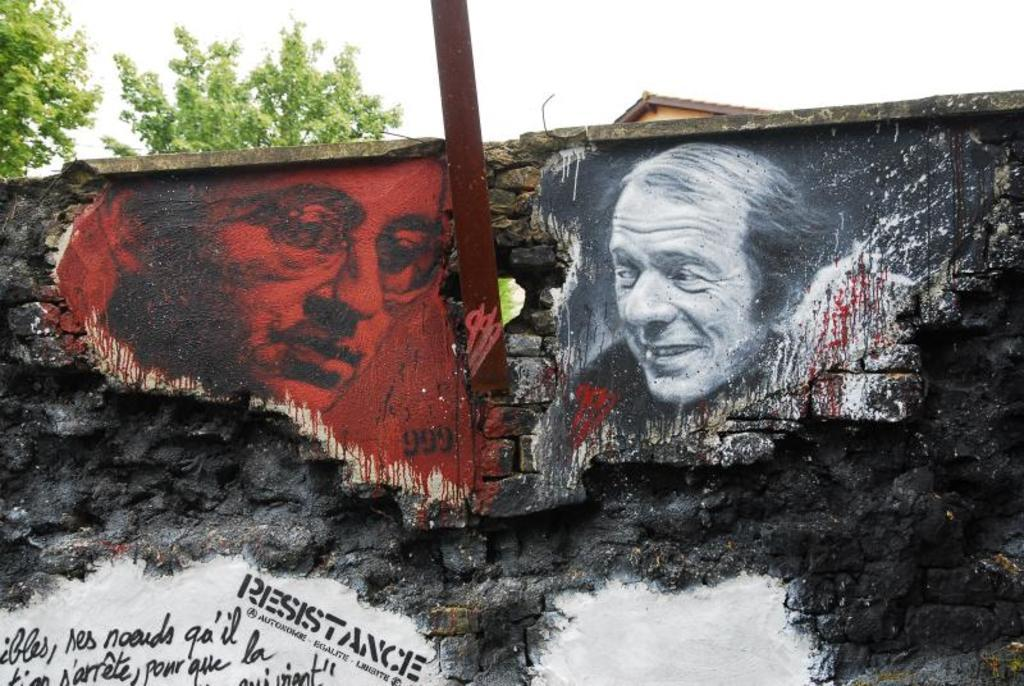What is present on the wall in the image? There are pictures of two men on the wall, along with text. What is the material of the rod in the image? The rod in the image is made of metal. What type of vegetation can be seen in the image? There are trees in the image. What is visible in the background of the image? The sky is visible in the image. Can you see any ladybugs crawling on the wall in the image? There are no ladybugs present on the wall or in the image. What type of flame can be seen coming from the trees in the image? There are no flames visible in the image, and the trees do not appear to be on fire. 